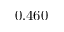Convert formula to latex. <formula><loc_0><loc_0><loc_500><loc_500>0 . 4 6 0</formula> 